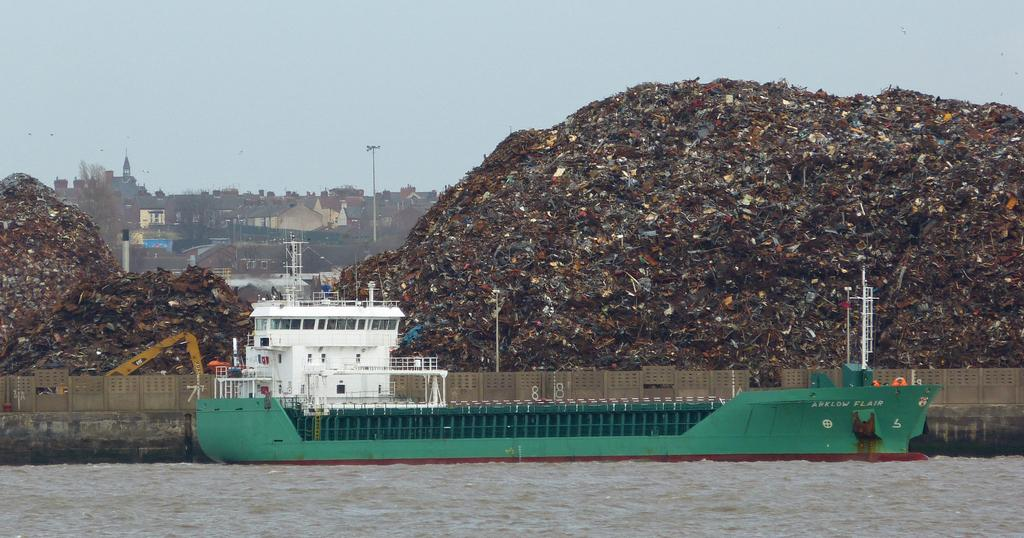What body of water is present at the bottom of the image? There is a river at the bottom of the image. What is in the river? There is a boat in the river. What can be seen in the background of the image? There is scrap, buildings, and poles in the background of the image. What is visible at the top of the image? The sky is visible at the top of the image. Where is the sofa located in the image? There is no sofa present in the image. What type of class is being taught in the background of the image? There is no class or educational activity depicted in the image. 